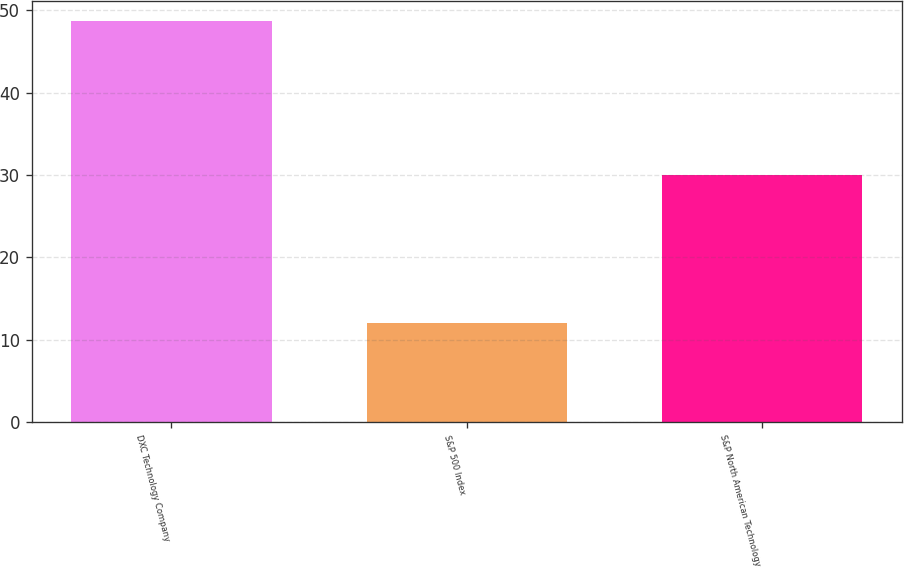Convert chart to OTSL. <chart><loc_0><loc_0><loc_500><loc_500><bar_chart><fcel>DXC Technology Company<fcel>S&P 500 Index<fcel>S&P North American Technology<nl><fcel>48.7<fcel>12<fcel>30<nl></chart> 